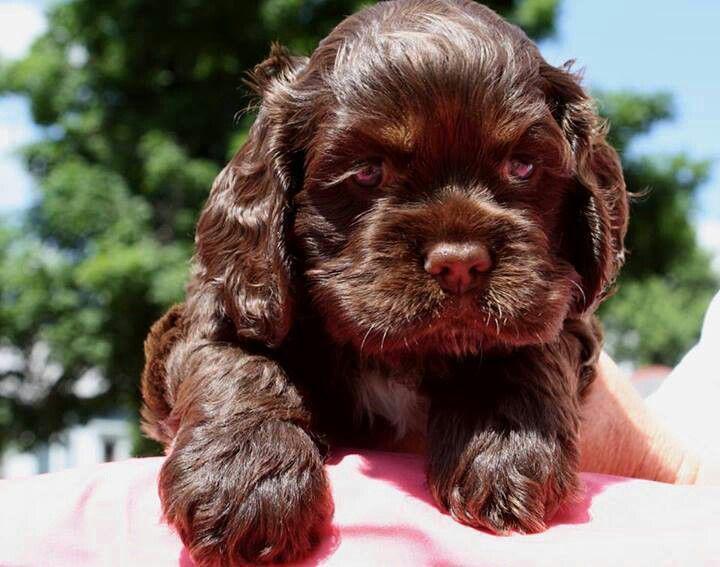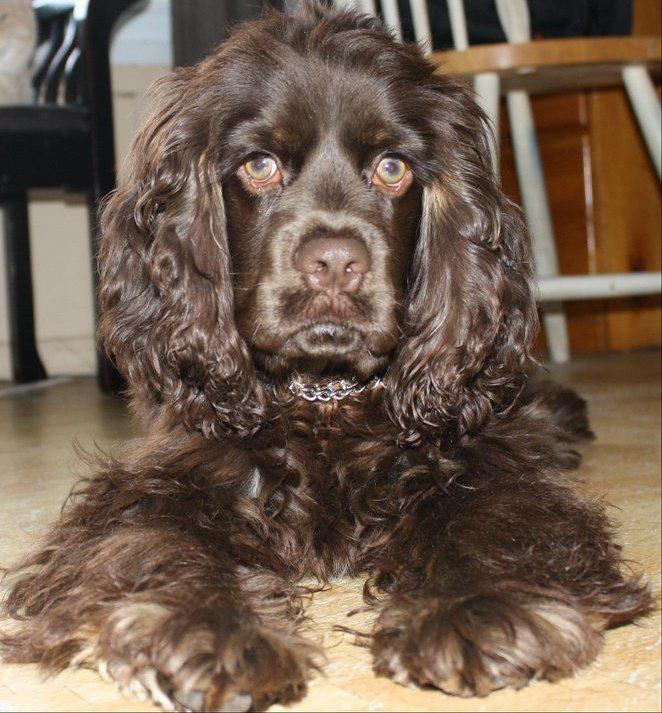The first image is the image on the left, the second image is the image on the right. Given the left and right images, does the statement "One dog is outside in one of the images." hold true? Answer yes or no. Yes. 